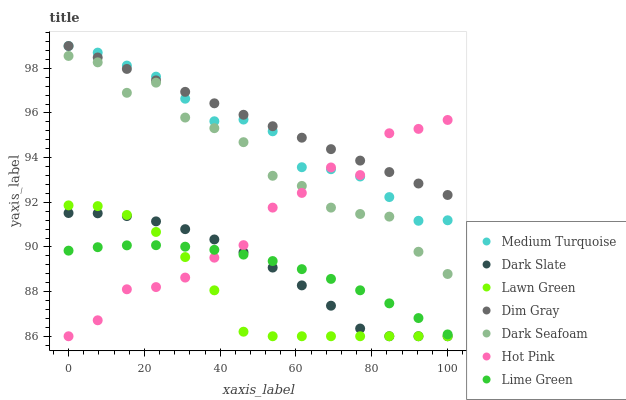Does Lawn Green have the minimum area under the curve?
Answer yes or no. Yes. Does Dim Gray have the maximum area under the curve?
Answer yes or no. Yes. Does Hot Pink have the minimum area under the curve?
Answer yes or no. No. Does Hot Pink have the maximum area under the curve?
Answer yes or no. No. Is Dim Gray the smoothest?
Answer yes or no. Yes. Is Dark Seafoam the roughest?
Answer yes or no. Yes. Is Hot Pink the smoothest?
Answer yes or no. No. Is Hot Pink the roughest?
Answer yes or no. No. Does Lawn Green have the lowest value?
Answer yes or no. Yes. Does Dim Gray have the lowest value?
Answer yes or no. No. Does Medium Turquoise have the highest value?
Answer yes or no. Yes. Does Hot Pink have the highest value?
Answer yes or no. No. Is Dark Slate less than Dark Seafoam?
Answer yes or no. Yes. Is Medium Turquoise greater than Lawn Green?
Answer yes or no. Yes. Does Medium Turquoise intersect Dim Gray?
Answer yes or no. Yes. Is Medium Turquoise less than Dim Gray?
Answer yes or no. No. Is Medium Turquoise greater than Dim Gray?
Answer yes or no. No. Does Dark Slate intersect Dark Seafoam?
Answer yes or no. No. 